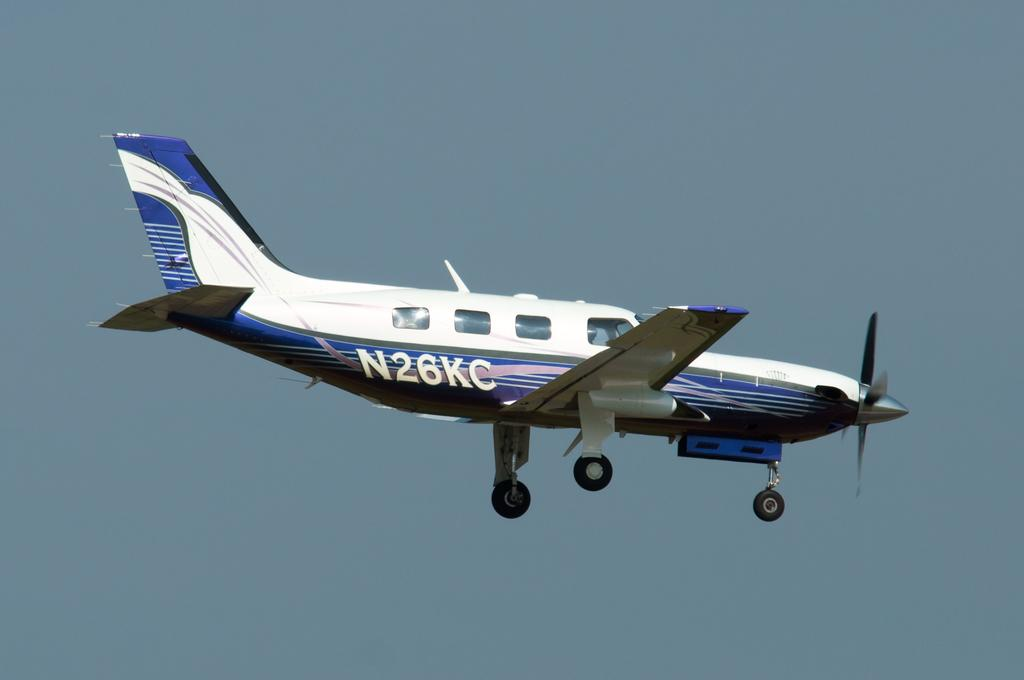<image>
Relay a brief, clear account of the picture shown. a small plane has serial number N26KC on the side 